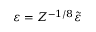Convert formula to latex. <formula><loc_0><loc_0><loc_500><loc_500>\varepsilon = Z ^ { - 1 / 8 } \tilde { \varepsilon }</formula> 